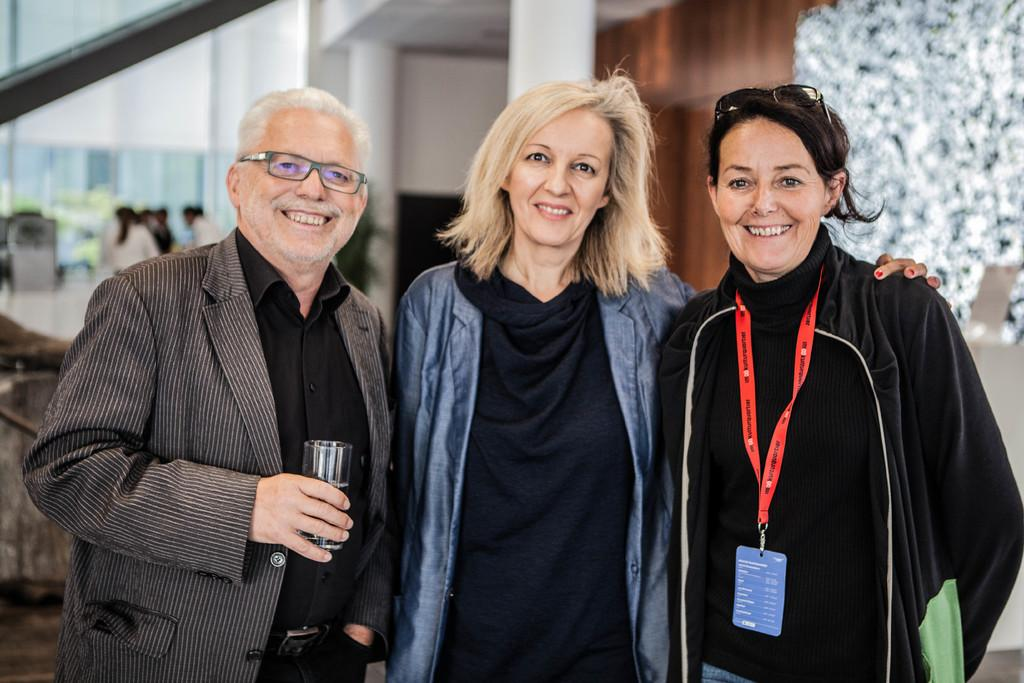How many people are present in the image? There are three people in the image: one man and two women. What are the people in the image doing? The man and women are standing and smiling. What is the man holding in the image? The man is holding a glass with his hand. What can be seen in the background of the image? There are pillars, a wall, and people visible in the background of the image. What type of knot is the man tying in the image? There is no knot present in the image; the man is holding a glass with his hand. What type of service is the man providing to the women in the image? There is no indication of any service being provided in the image; the man and women are simply standing and smiling. 